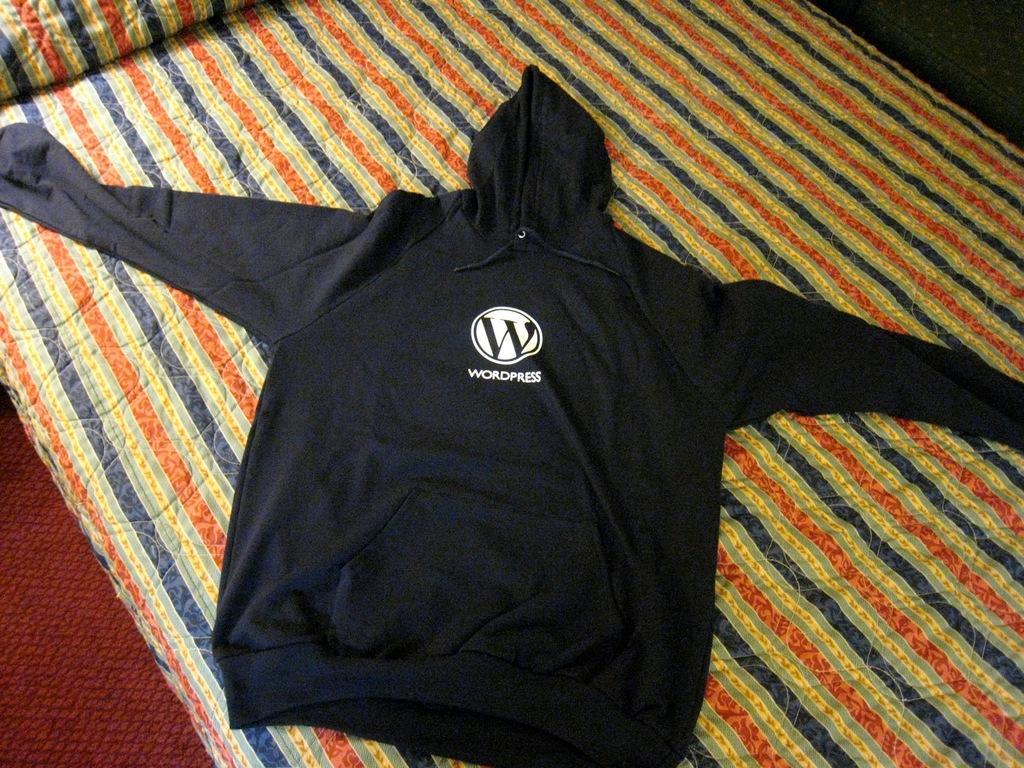How would you summarize this image in a sentence or two? In this picture I can see a hoodie on the blanket and looks like a carpet on the left side of the image. 